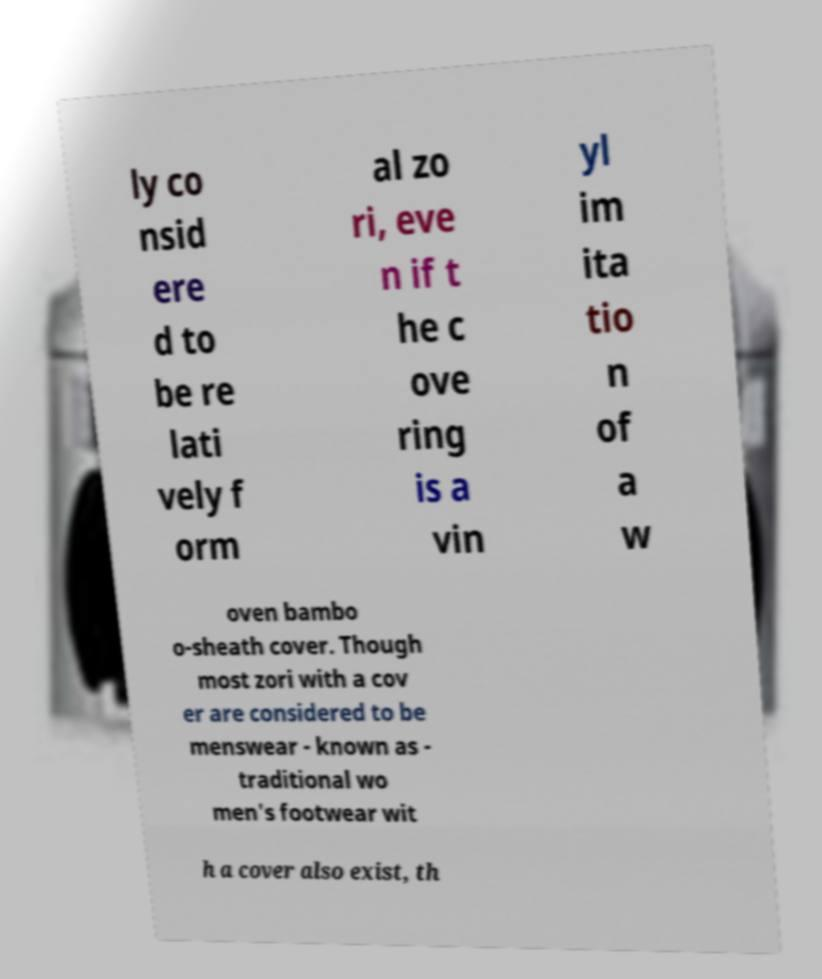Can you read and provide the text displayed in the image?This photo seems to have some interesting text. Can you extract and type it out for me? ly co nsid ere d to be re lati vely f orm al zo ri, eve n if t he c ove ring is a vin yl im ita tio n of a w oven bambo o-sheath cover. Though most zori with a cov er are considered to be menswear - known as - traditional wo men's footwear wit h a cover also exist, th 